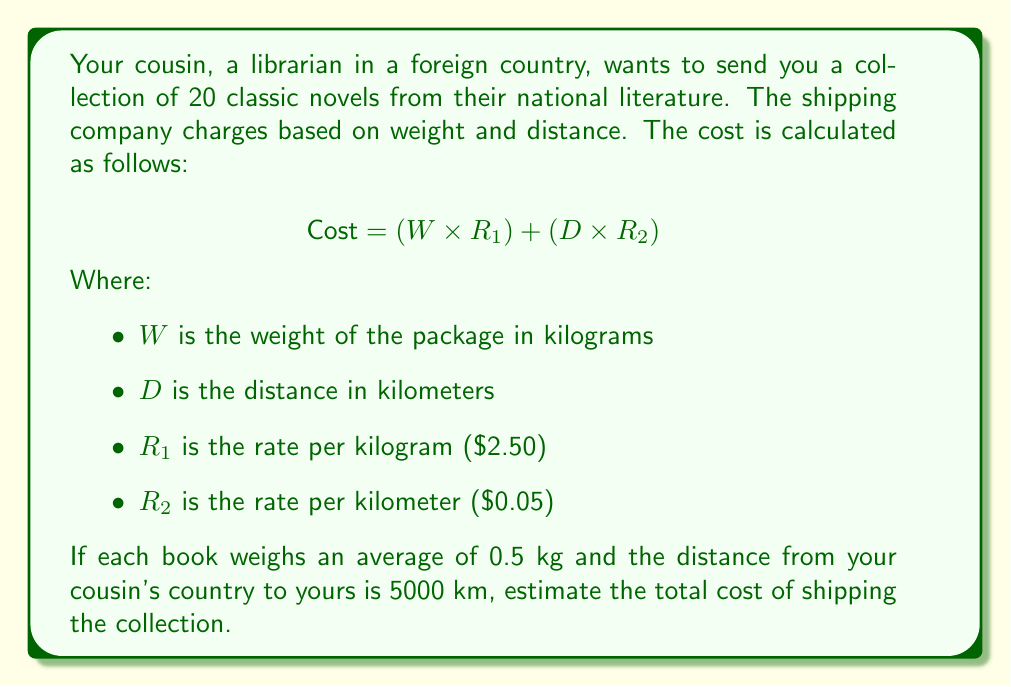Can you answer this question? Let's break this down step-by-step:

1. Calculate the total weight of the package:
   $$ W = 20 \text{ books} \times 0.5 \text{ kg/book} = 10 \text{ kg} $$

2. We know the distance $D = 5000 \text{ km}$

3. Apply the given formula:
   $$ \text{Cost} = (W \times R_1) + (D \times R_2) $$

4. Substitute the values:
   $$ \text{Cost} = (10 \times 2.50) + (5000 \times 0.05) $$

5. Calculate each part:
   $$ \text{Cost} = 25 + 250 $$

6. Sum up the total:
   $$ \text{Cost} = 275 $$

Therefore, the estimated cost of shipping the collection is $275.
Answer: $275 